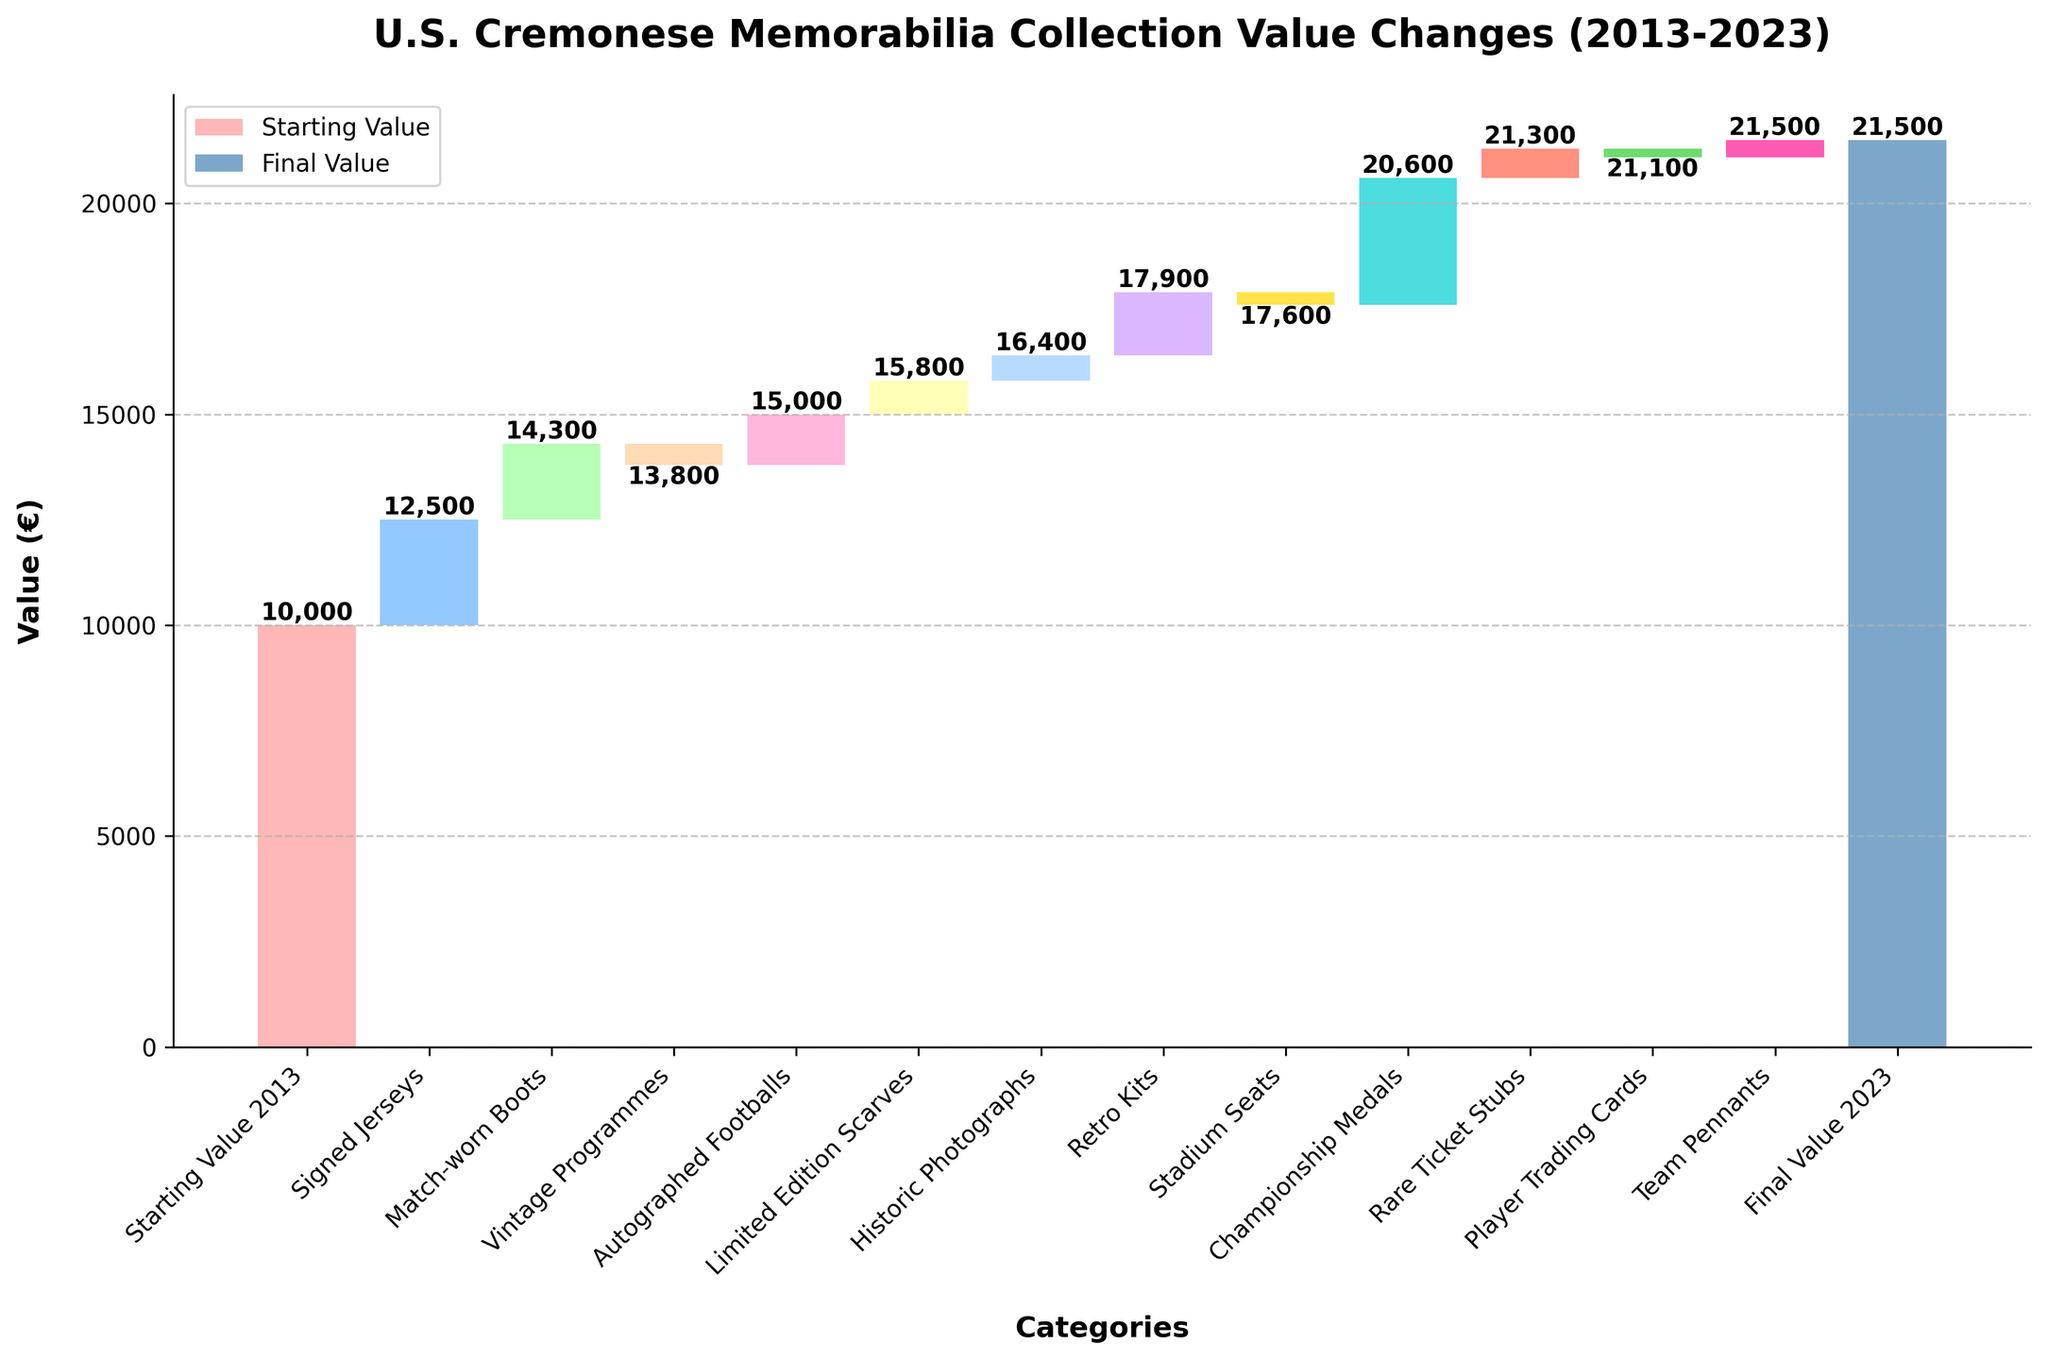What is the starting value of the collection in 2013? The starting value is the first value plotted on the chart, represented by the bar labeled "Starting Value 2013".
Answer: 10,000 Which category contributed the most to the increase in value over the decade? The category with the highest positive value contributes the most to the increase. The highest positive value is "Championship Medals" with 3,000.
Answer: Championship Medals Which category had a negative impact on the collection's value? We look for categories with negative values. Two categories have negative values: "Vintage Programmes" (-500) and "Player Trading Cards" (-200).
Answer: Vintage Programmes and Player Trading Cards What is the final value of the memorabilia collection in 2023? The final value is the last value plotted on the chart, represented by the bar labeled "Final Value 2023".
Answer: 21,500 How much did the "Autographed Footballs" category add to the value of the collection? The value added by "Autographed Footballs" can be directly read from the bar representing this category, which is 1,200.
Answer: 1,200 What is the net change in value contributed by all categories related to apparel (Signed Jerseys, Limited Edition Scarves, Retro Kits)? Sum the values for "Signed Jerseys" (2,500), "Limited Edition Scarves" (800), and "Retro Kits" (1,500): 2,500 + 800 + 1,500 = 4,800.
Answer: 4,800 Which categories provided relatively smaller positive contributions to the collection's value? Examine categories with positive values and compare their magnitudes. The smaller contributions are from "Team Pennants" (400), "Historic Photographs" (600), and "Rare Ticket Stubs" (700).
Answer: Team Pennants, Historic Photographs, and Rare Ticket Stubs Compare the contributions of "Match-worn Boots" and "Signed Jerseys" to the overall value increase. "Match-worn Boots" contributed 1,800 while "Signed Jerseys" contributed 2,500. Comparing these values, "Signed Jerseys" contributed more.
Answer: Signed Jerseys contributed more Which category nearly offset the value added by "Historic Photographs"? "Historic Photographs" added a value of 600. The category with a value close to -600 is "Vintage Programmes" with -500.
Answer: Vintage Programmes How did rare collectibles (Championship Medals, Rare Ticket Stubs, Player Trading Cards) impact the collection overall? Sum the values for "Championship Medals" (3,000), "Rare Ticket Stubs" (700), and "Player Trading Cards" (-200): 3,000 + 700 - 200 = 3,500.
Answer: 3,500 